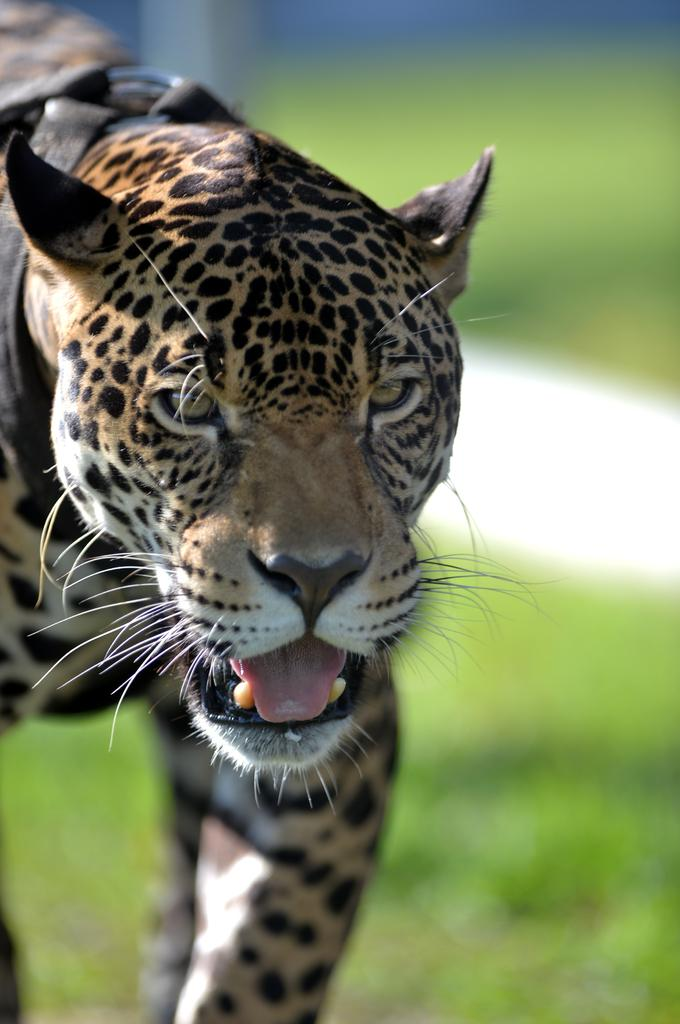What animal is on the left side of the image? There is a cheetah on the left side of the image. What can be observed about the right side of the image? The right side of the image is blurry. What type of vegetation is at the bottom of the image? There is grass at the bottom of the image. What type of linen is draped over the cheetah in the image? There is no linen present in the image; the cheetah is not covered by any fabric. What observation can be made about the cheetah's behavior in the image? The image does not show the cheetah's behavior, as it is a still image. 